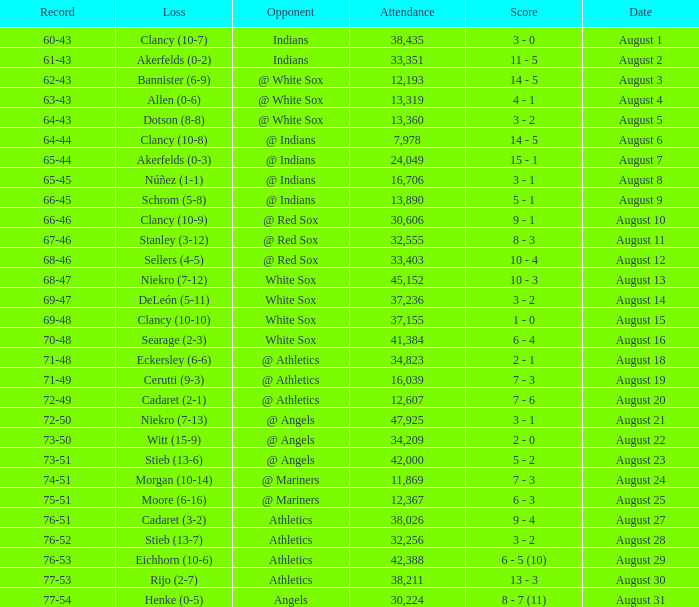What was the attendance when the record was 77-54? 30224.0. 